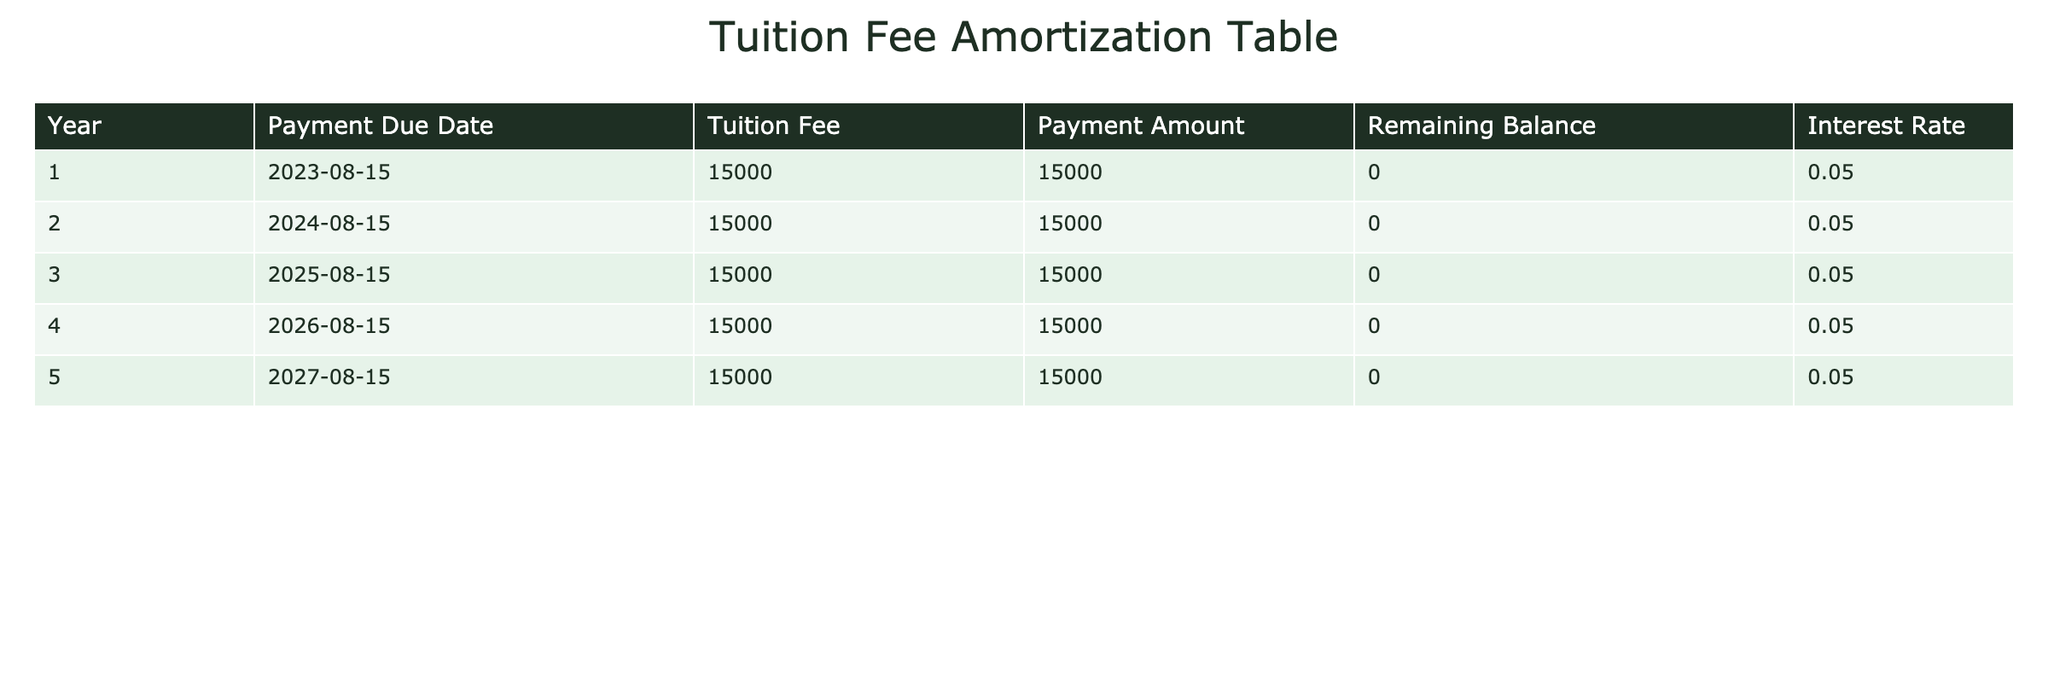What is the total tuition fee for the entire academic program? To find the total tuition fee, I sum the tuition fees from all years: 15000 (Year 1) + 15000 (Year 2) + 15000 (Year 3) + 15000 (Year 4) + 15000 (Year 5) = 75000.
Answer: 75000 What is the payment amount for Year 3? The payment amount for Year 3 is listed directly in the table as 15000.
Answer: 15000 Is the remaining balance ever greater than zero? The remaining balance for each year is consistently listed as zero across all years, indicating that there is never a greater than zero remaining balance.
Answer: No What is the average tuition fee per year over the multi-year program? The average tuition fee per year is calculated by taking the total tuition fee (75000) and dividing it by the number of years (5): 75000 / 5 = 15000.
Answer: 15000 Which year's payment amount matches the tuition fee? Every year's payment amount matches the tuition fee since they are consistently 15000 for all years.
Answer: All years What is the total amount paid at the end of Year 4? At the end of Year 4, a total payment of 15000 (Year 1) + 15000 (Year 2) + 15000 (Year 3) + 15000 (Year 4) equals 60000.
Answer: 60000 Are all interest rates for the years the same? The interest rate is consistently listed as 0.05 for each of the five years, indicating that they are all the same.
Answer: Yes If a student made no payments, what would the remaining balance be after 5 years? Since no payments were made, the remaining balance would remain consistent at 15000 for each year, leading to a total remaining balance of 75000 after 5 years.
Answer: 75000 How much would a student pay over the first two years combined? The total payment over the first two years is 15000 (Year 1) + 15000 (Year 2) = 30000.
Answer: 30000 